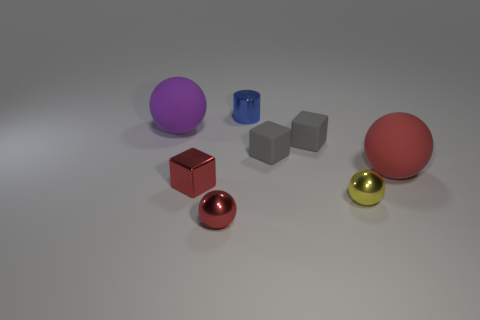How many gray cubes must be subtracted to get 1 gray cubes? 1 Subtract 1 spheres. How many spheres are left? 3 Subtract all purple cubes. How many red spheres are left? 2 Subtract all gray blocks. How many blocks are left? 1 Subtract all purple balls. How many balls are left? 3 Subtract all brown spheres. Subtract all yellow cubes. How many spheres are left? 4 Add 2 big red matte spheres. How many objects exist? 10 Subtract all cylinders. How many objects are left? 7 Add 2 red shiny cylinders. How many red shiny cylinders exist? 2 Subtract 0 purple blocks. How many objects are left? 8 